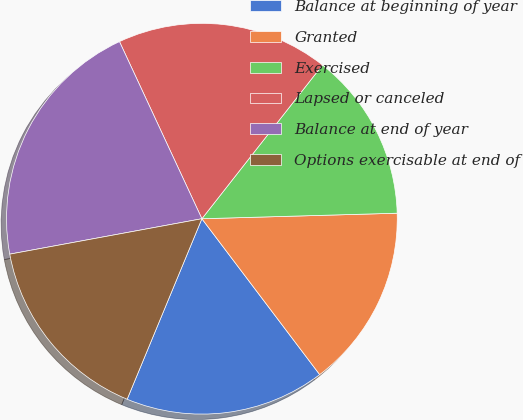Convert chart to OTSL. <chart><loc_0><loc_0><loc_500><loc_500><pie_chart><fcel>Balance at beginning of year<fcel>Granted<fcel>Exercised<fcel>Lapsed or canceled<fcel>Balance at end of year<fcel>Options exercisable at end of<nl><fcel>16.55%<fcel>15.15%<fcel>13.96%<fcel>17.52%<fcel>20.97%<fcel>15.85%<nl></chart> 